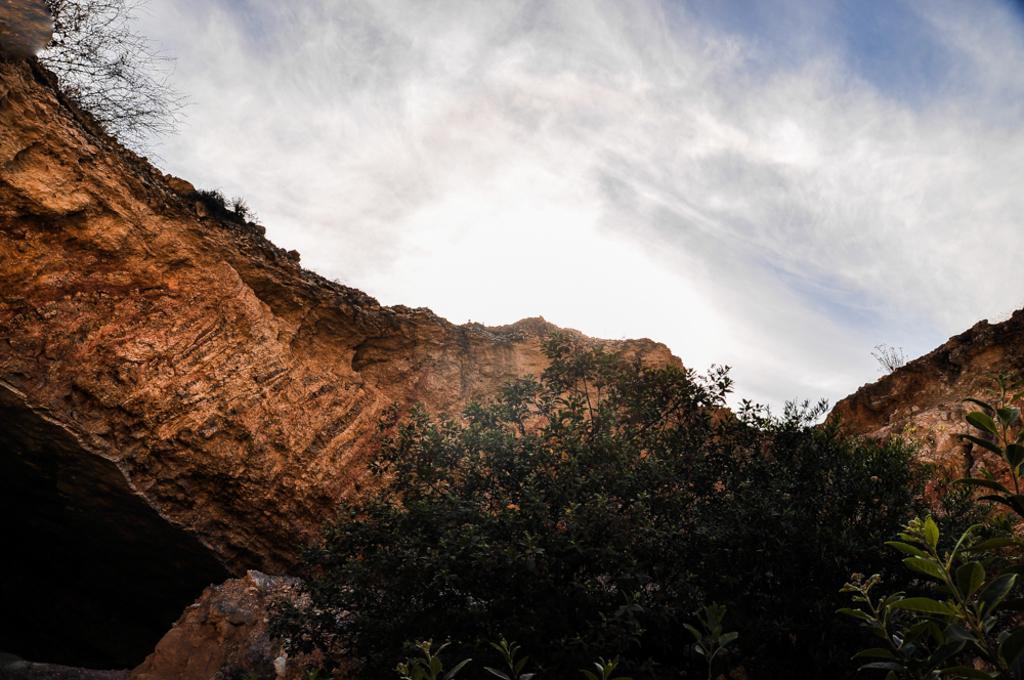Can you describe this image briefly? This picture is clicked outside. In the foreground we can see the plants and the rocks. On the left we can see a cave like object. In the background we can see the sky with the clouds and we can see the dry stems. 